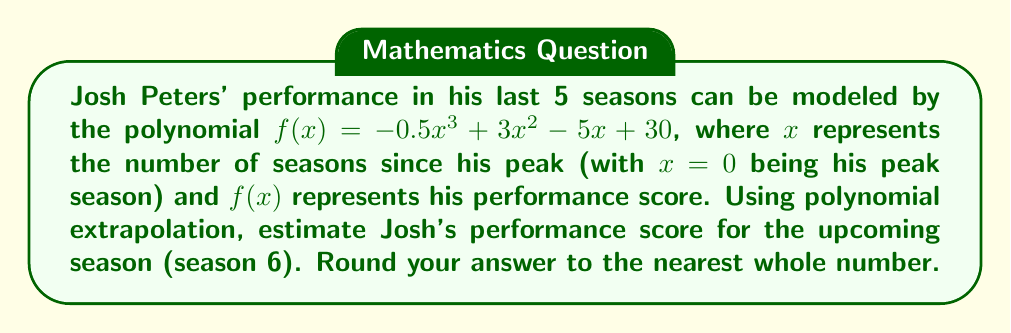Could you help me with this problem? To estimate Josh Peters' performance for the upcoming season, we need to evaluate $f(6)$ using the given polynomial function.

Let's break it down step-by-step:

1) The polynomial function is $f(x) = -0.5x^3 + 3x^2 - 5x + 30$

2) We need to calculate $f(6)$:

   $f(6) = -0.5(6^3) + 3(6^2) - 5(6) + 30$

3) Let's evaluate each term:
   
   $-0.5(6^3) = -0.5(216) = -108$
   $3(6^2) = 3(36) = 108$
   $-5(6) = -30$
   $30$ remains as is

4) Now, let's sum up all the terms:

   $f(6) = -108 + 108 - 30 + 30 = 0$

5) The result is exactly 0, so no rounding is necessary.

This polynomial extrapolation suggests that Josh Peters' performance will continue to decline, reaching a score of 0 in the upcoming season, which aligns with the persona's disappointment in his waning career.
Answer: 0 